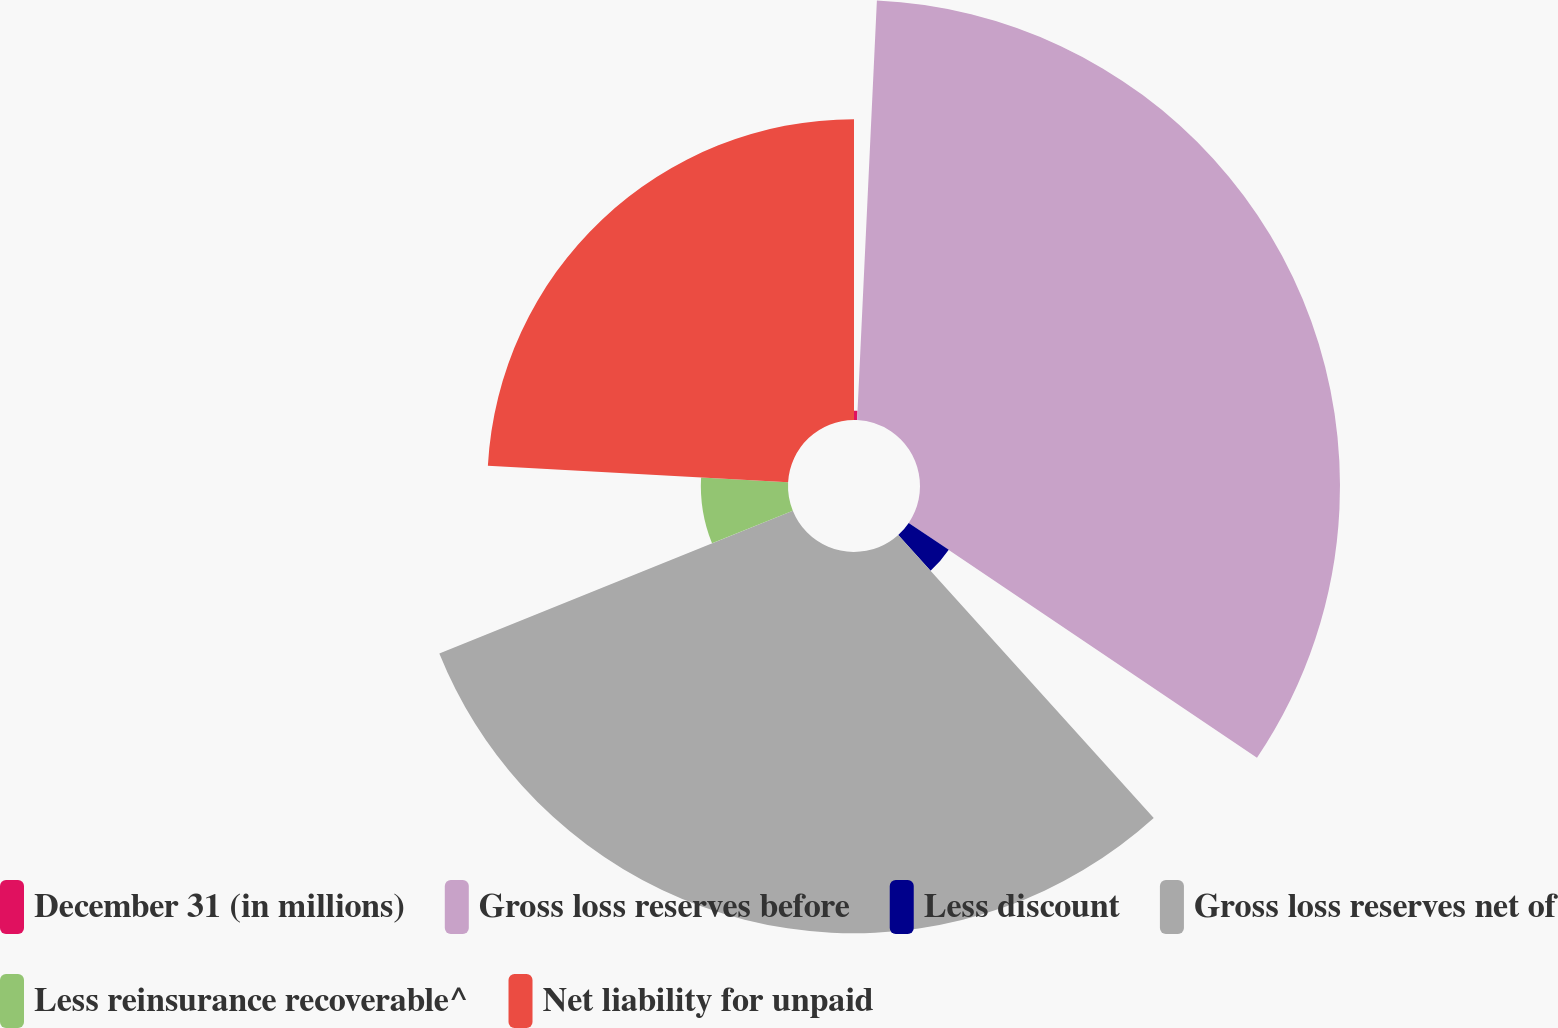Convert chart to OTSL. <chart><loc_0><loc_0><loc_500><loc_500><pie_chart><fcel>December 31 (in millions)<fcel>Gross loss reserves before<fcel>Less discount<fcel>Gross loss reserves net of<fcel>Less reinsurance recoverable^<fcel>Net liability for unpaid<nl><fcel>0.75%<fcel>33.69%<fcel>3.87%<fcel>30.58%<fcel>6.99%<fcel>24.12%<nl></chart> 